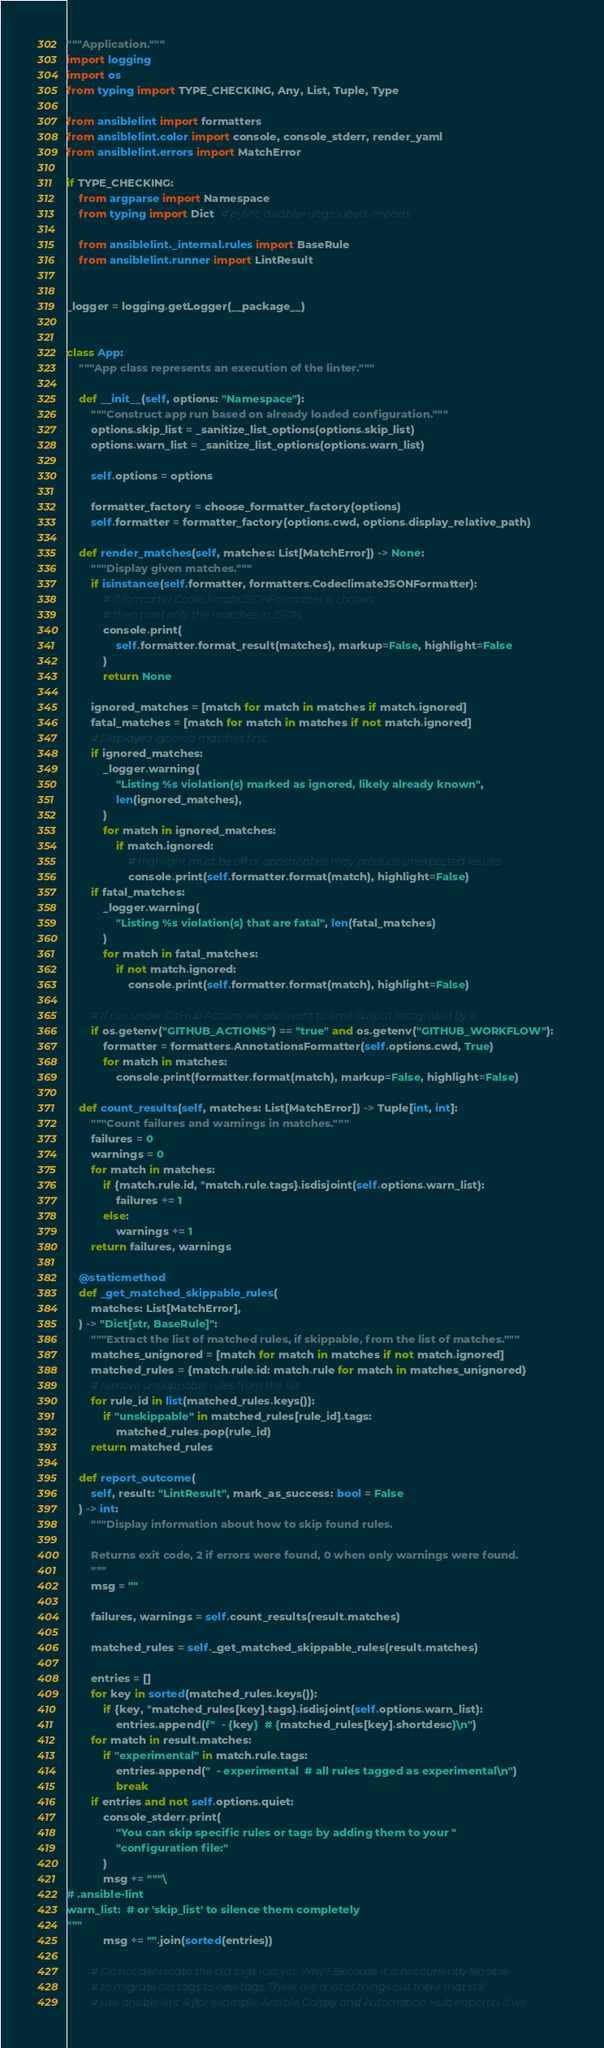<code> <loc_0><loc_0><loc_500><loc_500><_Python_>"""Application."""
import logging
import os
from typing import TYPE_CHECKING, Any, List, Tuple, Type

from ansiblelint import formatters
from ansiblelint.color import console, console_stderr, render_yaml
from ansiblelint.errors import MatchError

if TYPE_CHECKING:
    from argparse import Namespace
    from typing import Dict  # pylint: disable=ungrouped-imports

    from ansiblelint._internal.rules import BaseRule
    from ansiblelint.runner import LintResult


_logger = logging.getLogger(__package__)


class App:
    """App class represents an execution of the linter."""

    def __init__(self, options: "Namespace"):
        """Construct app run based on already loaded configuration."""
        options.skip_list = _sanitize_list_options(options.skip_list)
        options.warn_list = _sanitize_list_options(options.warn_list)

        self.options = options

        formatter_factory = choose_formatter_factory(options)
        self.formatter = formatter_factory(options.cwd, options.display_relative_path)

    def render_matches(self, matches: List[MatchError]) -> None:
        """Display given matches."""
        if isinstance(self.formatter, formatters.CodeclimateJSONFormatter):
            # If formatter CodeclimateJSONFormatter is chosen,
            # then print only the matches in JSON
            console.print(
                self.formatter.format_result(matches), markup=False, highlight=False
            )
            return None

        ignored_matches = [match for match in matches if match.ignored]
        fatal_matches = [match for match in matches if not match.ignored]
        # Displayed ignored matches first
        if ignored_matches:
            _logger.warning(
                "Listing %s violation(s) marked as ignored, likely already known",
                len(ignored_matches),
            )
            for match in ignored_matches:
                if match.ignored:
                    # highlight must be off or apostrophes may produce unexpected results
                    console.print(self.formatter.format(match), highlight=False)
        if fatal_matches:
            _logger.warning(
                "Listing %s violation(s) that are fatal", len(fatal_matches)
            )
            for match in fatal_matches:
                if not match.ignored:
                    console.print(self.formatter.format(match), highlight=False)

        # If run under GitHub Actions we also want to emit output recognized by it.
        if os.getenv("GITHUB_ACTIONS") == "true" and os.getenv("GITHUB_WORKFLOW"):
            formatter = formatters.AnnotationsFormatter(self.options.cwd, True)
            for match in matches:
                console.print(formatter.format(match), markup=False, highlight=False)

    def count_results(self, matches: List[MatchError]) -> Tuple[int, int]:
        """Count failures and warnings in matches."""
        failures = 0
        warnings = 0
        for match in matches:
            if {match.rule.id, *match.rule.tags}.isdisjoint(self.options.warn_list):
                failures += 1
            else:
                warnings += 1
        return failures, warnings

    @staticmethod
    def _get_matched_skippable_rules(
        matches: List[MatchError],
    ) -> "Dict[str, BaseRule]":
        """Extract the list of matched rules, if skippable, from the list of matches."""
        matches_unignored = [match for match in matches if not match.ignored]
        matched_rules = {match.rule.id: match.rule for match in matches_unignored}
        # remove unskippable rules from the list
        for rule_id in list(matched_rules.keys()):
            if "unskippable" in matched_rules[rule_id].tags:
                matched_rules.pop(rule_id)
        return matched_rules

    def report_outcome(
        self, result: "LintResult", mark_as_success: bool = False
    ) -> int:
        """Display information about how to skip found rules.

        Returns exit code, 2 if errors were found, 0 when only warnings were found.
        """
        msg = ""

        failures, warnings = self.count_results(result.matches)

        matched_rules = self._get_matched_skippable_rules(result.matches)

        entries = []
        for key in sorted(matched_rules.keys()):
            if {key, *matched_rules[key].tags}.isdisjoint(self.options.warn_list):
                entries.append(f"  - {key}  # {matched_rules[key].shortdesc}\n")
        for match in result.matches:
            if "experimental" in match.rule.tags:
                entries.append("  - experimental  # all rules tagged as experimental\n")
                break
        if entries and not self.options.quiet:
            console_stderr.print(
                "You can skip specific rules or tags by adding them to your "
                "configuration file:"
            )
            msg += """\
# .ansible-lint
warn_list:  # or 'skip_list' to silence them completely
"""
            msg += "".join(sorted(entries))

        # Do not deprecate the old tags just yet. Why? Because it is not currently feasible
        # to migrate old tags to new tags. There are a lot of things out there that still
        # use ansible-lint 4 (for example, Ansible Galaxy and Automation Hub imports). If we</code> 